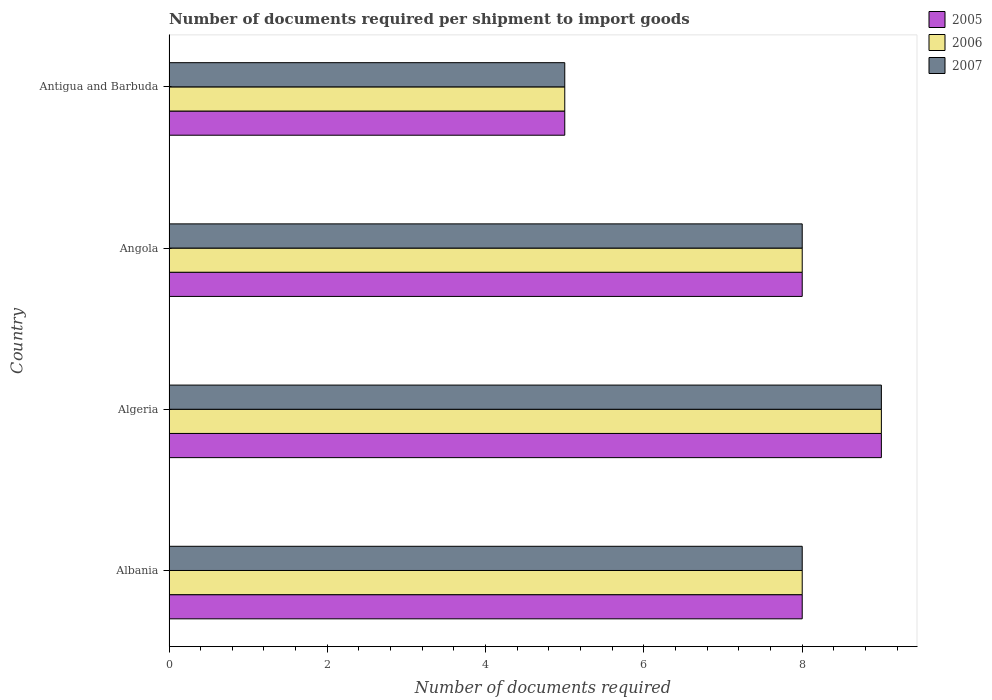How many different coloured bars are there?
Offer a very short reply. 3. How many groups of bars are there?
Provide a succinct answer. 4. Are the number of bars per tick equal to the number of legend labels?
Keep it short and to the point. Yes. How many bars are there on the 1st tick from the top?
Your answer should be compact. 3. How many bars are there on the 3rd tick from the bottom?
Ensure brevity in your answer.  3. What is the label of the 2nd group of bars from the top?
Your answer should be very brief. Angola. What is the number of documents required per shipment to import goods in 2006 in Angola?
Give a very brief answer. 8. Across all countries, what is the minimum number of documents required per shipment to import goods in 2007?
Provide a succinct answer. 5. In which country was the number of documents required per shipment to import goods in 2007 maximum?
Ensure brevity in your answer.  Algeria. In which country was the number of documents required per shipment to import goods in 2006 minimum?
Provide a short and direct response. Antigua and Barbuda. What is the total number of documents required per shipment to import goods in 2006 in the graph?
Your answer should be compact. 30. What is the difference between the number of documents required per shipment to import goods in 2007 in Algeria and that in Angola?
Keep it short and to the point. 1. What is the difference between the number of documents required per shipment to import goods in 2007 in Albania and the number of documents required per shipment to import goods in 2005 in Angola?
Ensure brevity in your answer.  0. What is the average number of documents required per shipment to import goods in 2007 per country?
Provide a succinct answer. 7.5. What is the difference between the number of documents required per shipment to import goods in 2006 and number of documents required per shipment to import goods in 2005 in Antigua and Barbuda?
Ensure brevity in your answer.  0. Is the number of documents required per shipment to import goods in 2006 in Albania less than that in Antigua and Barbuda?
Offer a terse response. No. What is the difference between the highest and the lowest number of documents required per shipment to import goods in 2007?
Offer a very short reply. 4. How many bars are there?
Ensure brevity in your answer.  12. Are all the bars in the graph horizontal?
Provide a succinct answer. Yes. Are the values on the major ticks of X-axis written in scientific E-notation?
Your response must be concise. No. Does the graph contain grids?
Your answer should be compact. No. How are the legend labels stacked?
Give a very brief answer. Vertical. What is the title of the graph?
Provide a short and direct response. Number of documents required per shipment to import goods. What is the label or title of the X-axis?
Provide a succinct answer. Number of documents required. What is the Number of documents required of 2006 in Albania?
Offer a terse response. 8. What is the Number of documents required of 2007 in Albania?
Your answer should be very brief. 8. What is the Number of documents required in 2006 in Algeria?
Your answer should be very brief. 9. What is the Number of documents required of 2005 in Angola?
Make the answer very short. 8. What is the Number of documents required of 2006 in Angola?
Offer a very short reply. 8. What is the Number of documents required in 2005 in Antigua and Barbuda?
Your answer should be compact. 5. What is the Number of documents required of 2006 in Antigua and Barbuda?
Give a very brief answer. 5. Across all countries, what is the maximum Number of documents required of 2005?
Your answer should be compact. 9. Across all countries, what is the maximum Number of documents required in 2006?
Your answer should be very brief. 9. Across all countries, what is the maximum Number of documents required in 2007?
Offer a terse response. 9. What is the total Number of documents required of 2005 in the graph?
Ensure brevity in your answer.  30. What is the total Number of documents required of 2006 in the graph?
Offer a very short reply. 30. What is the total Number of documents required in 2007 in the graph?
Provide a succinct answer. 30. What is the difference between the Number of documents required in 2006 in Albania and that in Algeria?
Offer a terse response. -1. What is the difference between the Number of documents required in 2005 in Albania and that in Angola?
Offer a terse response. 0. What is the difference between the Number of documents required of 2006 in Albania and that in Angola?
Offer a terse response. 0. What is the difference between the Number of documents required of 2007 in Albania and that in Angola?
Keep it short and to the point. 0. What is the difference between the Number of documents required in 2005 in Albania and that in Antigua and Barbuda?
Give a very brief answer. 3. What is the difference between the Number of documents required of 2006 in Albania and that in Antigua and Barbuda?
Give a very brief answer. 3. What is the difference between the Number of documents required of 2007 in Albania and that in Antigua and Barbuda?
Your answer should be very brief. 3. What is the difference between the Number of documents required of 2005 in Algeria and that in Angola?
Your response must be concise. 1. What is the difference between the Number of documents required in 2005 in Angola and that in Antigua and Barbuda?
Ensure brevity in your answer.  3. What is the difference between the Number of documents required in 2006 in Angola and that in Antigua and Barbuda?
Your answer should be compact. 3. What is the difference between the Number of documents required in 2007 in Angola and that in Antigua and Barbuda?
Your response must be concise. 3. What is the difference between the Number of documents required in 2005 in Albania and the Number of documents required in 2006 in Algeria?
Keep it short and to the point. -1. What is the difference between the Number of documents required of 2005 in Albania and the Number of documents required of 2007 in Algeria?
Ensure brevity in your answer.  -1. What is the difference between the Number of documents required of 2005 in Albania and the Number of documents required of 2006 in Angola?
Your response must be concise. 0. What is the difference between the Number of documents required of 2005 in Albania and the Number of documents required of 2007 in Antigua and Barbuda?
Provide a succinct answer. 3. What is the difference between the Number of documents required of 2006 in Albania and the Number of documents required of 2007 in Antigua and Barbuda?
Your answer should be very brief. 3. What is the difference between the Number of documents required of 2005 in Algeria and the Number of documents required of 2006 in Angola?
Give a very brief answer. 1. What is the difference between the Number of documents required of 2006 in Algeria and the Number of documents required of 2007 in Antigua and Barbuda?
Make the answer very short. 4. What is the difference between the Number of documents required of 2005 in Angola and the Number of documents required of 2006 in Antigua and Barbuda?
Make the answer very short. 3. What is the difference between the Number of documents required of 2005 in Angola and the Number of documents required of 2007 in Antigua and Barbuda?
Your answer should be very brief. 3. What is the difference between the Number of documents required of 2006 in Angola and the Number of documents required of 2007 in Antigua and Barbuda?
Provide a short and direct response. 3. What is the average Number of documents required of 2005 per country?
Provide a short and direct response. 7.5. What is the average Number of documents required of 2006 per country?
Keep it short and to the point. 7.5. What is the difference between the Number of documents required of 2005 and Number of documents required of 2006 in Albania?
Keep it short and to the point. 0. What is the difference between the Number of documents required in 2005 and Number of documents required in 2007 in Albania?
Ensure brevity in your answer.  0. What is the difference between the Number of documents required of 2006 and Number of documents required of 2007 in Albania?
Offer a very short reply. 0. What is the difference between the Number of documents required of 2005 and Number of documents required of 2006 in Angola?
Make the answer very short. 0. What is the difference between the Number of documents required of 2005 and Number of documents required of 2007 in Angola?
Your answer should be very brief. 0. What is the difference between the Number of documents required in 2006 and Number of documents required in 2007 in Angola?
Ensure brevity in your answer.  0. What is the difference between the Number of documents required in 2005 and Number of documents required in 2007 in Antigua and Barbuda?
Your response must be concise. 0. What is the ratio of the Number of documents required of 2005 in Albania to that in Algeria?
Provide a short and direct response. 0.89. What is the ratio of the Number of documents required of 2007 in Albania to that in Algeria?
Offer a terse response. 0.89. What is the ratio of the Number of documents required in 2006 in Albania to that in Angola?
Ensure brevity in your answer.  1. What is the ratio of the Number of documents required of 2006 in Algeria to that in Angola?
Keep it short and to the point. 1.12. What is the ratio of the Number of documents required in 2005 in Algeria to that in Antigua and Barbuda?
Make the answer very short. 1.8. What is the ratio of the Number of documents required of 2006 in Algeria to that in Antigua and Barbuda?
Make the answer very short. 1.8. What is the ratio of the Number of documents required in 2007 in Algeria to that in Antigua and Barbuda?
Your answer should be compact. 1.8. What is the ratio of the Number of documents required in 2005 in Angola to that in Antigua and Barbuda?
Offer a very short reply. 1.6. What is the ratio of the Number of documents required of 2006 in Angola to that in Antigua and Barbuda?
Provide a short and direct response. 1.6. What is the difference between the highest and the second highest Number of documents required of 2007?
Your answer should be very brief. 1. What is the difference between the highest and the lowest Number of documents required of 2006?
Ensure brevity in your answer.  4. 